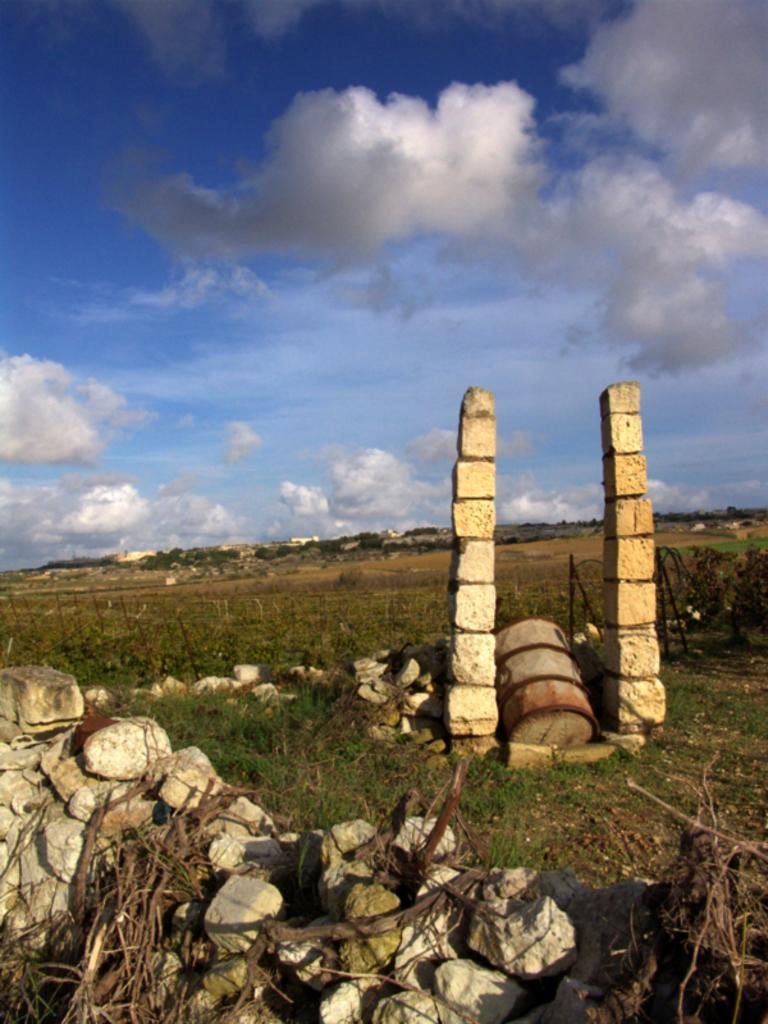What type of natural elements can be seen in the image? There are stones, grass, and trees in the image. What structures are visible in the background of the image? There are two pillars in the background of the image. What is the color of the grass and trees in the image? The grass and trees are green in color. What is the color of the sky in the image? The sky is blue and white in color. Can you tell me how many books are stacked on the aunt's head in the image? There is no aunt or books present in the image. What type of ocean can be seen in the image? There is no ocean visible in the image; it features stones, grass, trees, and pillars. 